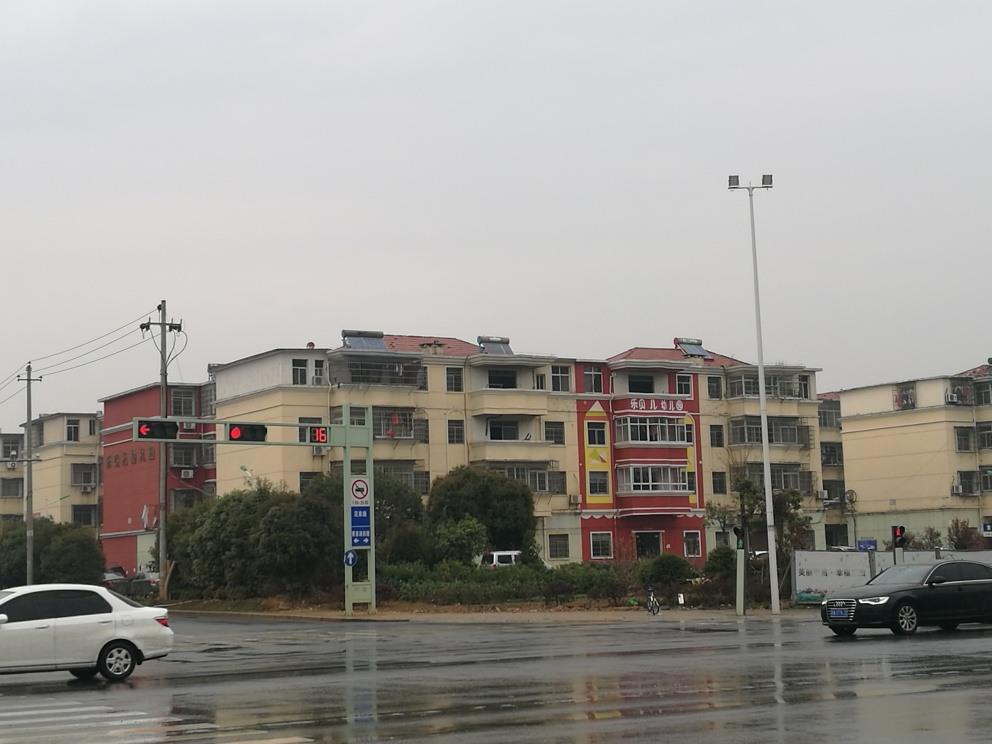Can you describe the weather conditions depicted in the image? The sky is overcast with a consistent grey tone, suggesting it might be an early morning or a cloudy day, with a considerable chance of recent or impending rain, as the road surface appears wet. There doesn't seem to be any direct sunlight or shadows, which aligns with an overcast weather condition. 